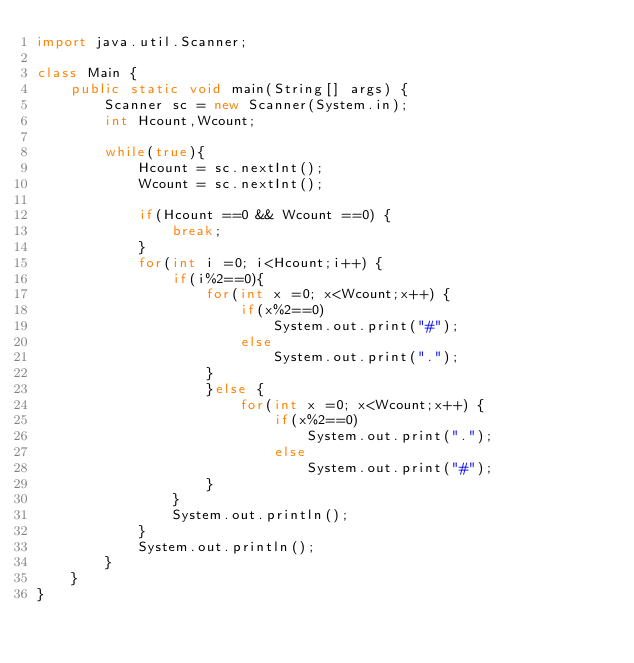Convert code to text. <code><loc_0><loc_0><loc_500><loc_500><_Java_>import java.util.Scanner;

class Main {
	public static void main(String[] args) {
		Scanner sc = new Scanner(System.in);
		int Hcount,Wcount;

		while(true){
			Hcount = sc.nextInt();
			Wcount = sc.nextInt();

			if(Hcount ==0 && Wcount ==0) {
				break;
			}
			for(int i =0; i<Hcount;i++) {
				if(i%2==0){
					for(int x =0; x<Wcount;x++) {
						if(x%2==0)
							System.out.print("#");
						else
							System.out.print(".");
					}
					}else {
						for(int x =0; x<Wcount;x++) {
							if(x%2==0)
								System.out.print(".");
							else
								System.out.print("#");
					}
				}
				System.out.println();
			}
			System.out.println();
		}
	}
}
</code> 